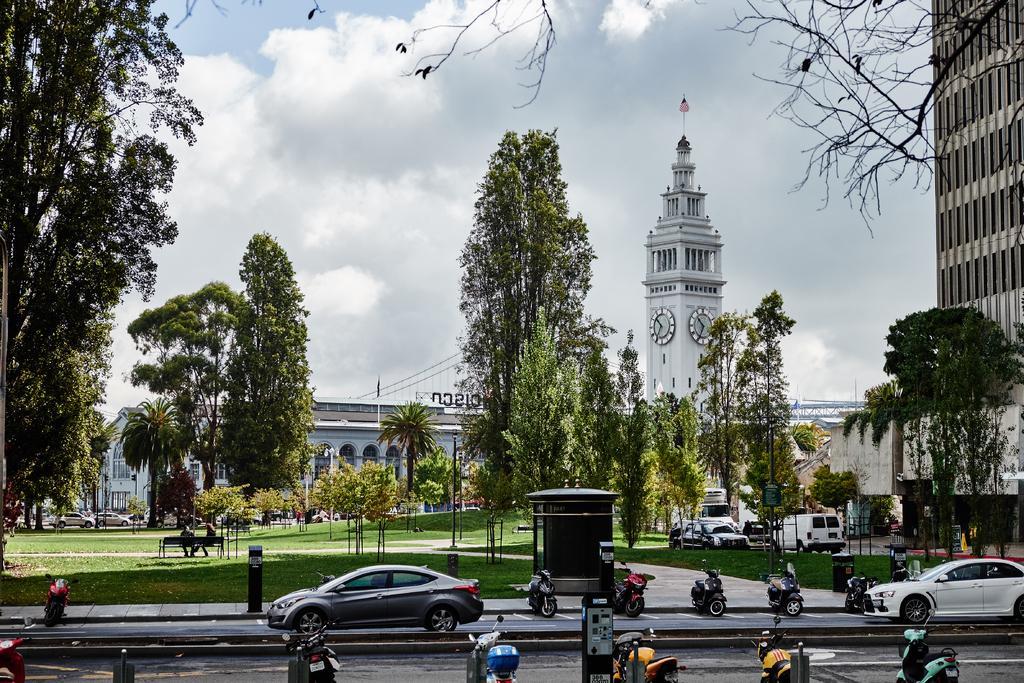Please provide a concise description of this image. In the foreground of the image there are vehicles on the road. In the background of the image there are buildings, trees. At the top of the image there is sky and clouds. 